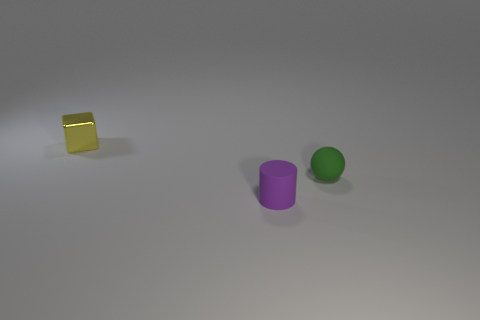Add 3 small red balls. How many objects exist? 6 Subtract all cylinders. How many objects are left? 2 Subtract all brown matte cubes. Subtract all matte balls. How many objects are left? 2 Add 2 small purple rubber things. How many small purple rubber things are left? 3 Add 2 tiny gray spheres. How many tiny gray spheres exist? 2 Subtract 0 brown blocks. How many objects are left? 3 